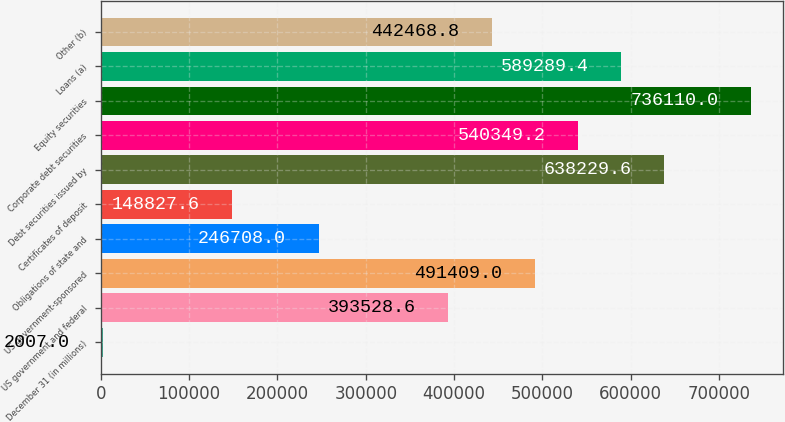Convert chart to OTSL. <chart><loc_0><loc_0><loc_500><loc_500><bar_chart><fcel>December 31 (in millions)<fcel>US government and federal<fcel>US government-sponsored<fcel>Obligations of state and<fcel>Certificates of deposit<fcel>Debt securities issued by<fcel>Corporate debt securities<fcel>Equity securities<fcel>Loans (a)<fcel>Other (b)<nl><fcel>2007<fcel>393529<fcel>491409<fcel>246708<fcel>148828<fcel>638230<fcel>540349<fcel>736110<fcel>589289<fcel>442469<nl></chart> 